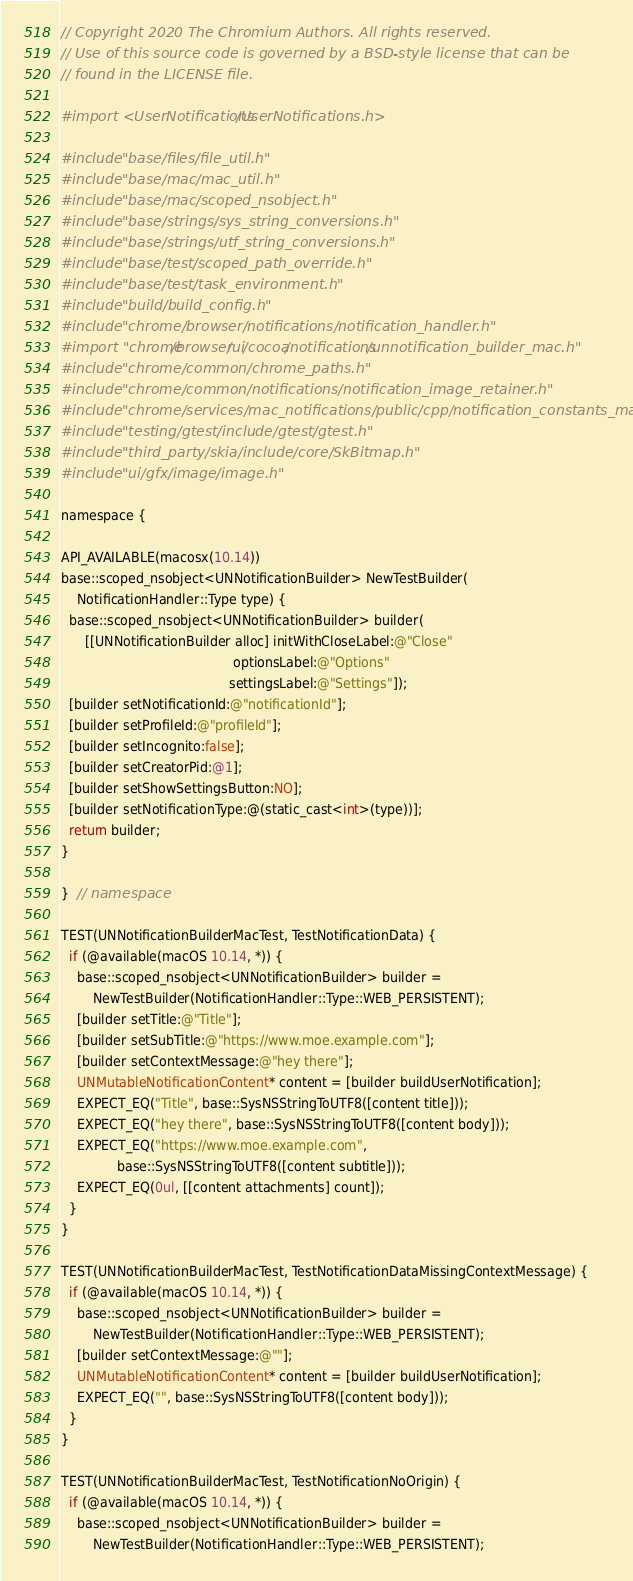Convert code to text. <code><loc_0><loc_0><loc_500><loc_500><_ObjectiveC_>// Copyright 2020 The Chromium Authors. All rights reserved.
// Use of this source code is governed by a BSD-style license that can be
// found in the LICENSE file.

#import <UserNotifications/UserNotifications.h>

#include "base/files/file_util.h"
#include "base/mac/mac_util.h"
#include "base/mac/scoped_nsobject.h"
#include "base/strings/sys_string_conversions.h"
#include "base/strings/utf_string_conversions.h"
#include "base/test/scoped_path_override.h"
#include "base/test/task_environment.h"
#include "build/build_config.h"
#include "chrome/browser/notifications/notification_handler.h"
#import "chrome/browser/ui/cocoa/notifications/unnotification_builder_mac.h"
#include "chrome/common/chrome_paths.h"
#include "chrome/common/notifications/notification_image_retainer.h"
#include "chrome/services/mac_notifications/public/cpp/notification_constants_mac.h"
#include "testing/gtest/include/gtest/gtest.h"
#include "third_party/skia/include/core/SkBitmap.h"
#include "ui/gfx/image/image.h"

namespace {

API_AVAILABLE(macosx(10.14))
base::scoped_nsobject<UNNotificationBuilder> NewTestBuilder(
    NotificationHandler::Type type) {
  base::scoped_nsobject<UNNotificationBuilder> builder(
      [[UNNotificationBuilder alloc] initWithCloseLabel:@"Close"
                                           optionsLabel:@"Options"
                                          settingsLabel:@"Settings"]);
  [builder setNotificationId:@"notificationId"];
  [builder setProfileId:@"profileId"];
  [builder setIncognito:false];
  [builder setCreatorPid:@1];
  [builder setShowSettingsButton:NO];
  [builder setNotificationType:@(static_cast<int>(type))];
  return builder;
}

}  // namespace

TEST(UNNotificationBuilderMacTest, TestNotificationData) {
  if (@available(macOS 10.14, *)) {
    base::scoped_nsobject<UNNotificationBuilder> builder =
        NewTestBuilder(NotificationHandler::Type::WEB_PERSISTENT);
    [builder setTitle:@"Title"];
    [builder setSubTitle:@"https://www.moe.example.com"];
    [builder setContextMessage:@"hey there"];
    UNMutableNotificationContent* content = [builder buildUserNotification];
    EXPECT_EQ("Title", base::SysNSStringToUTF8([content title]));
    EXPECT_EQ("hey there", base::SysNSStringToUTF8([content body]));
    EXPECT_EQ("https://www.moe.example.com",
              base::SysNSStringToUTF8([content subtitle]));
    EXPECT_EQ(0ul, [[content attachments] count]);
  }
}

TEST(UNNotificationBuilderMacTest, TestNotificationDataMissingContextMessage) {
  if (@available(macOS 10.14, *)) {
    base::scoped_nsobject<UNNotificationBuilder> builder =
        NewTestBuilder(NotificationHandler::Type::WEB_PERSISTENT);
    [builder setContextMessage:@""];
    UNMutableNotificationContent* content = [builder buildUserNotification];
    EXPECT_EQ("", base::SysNSStringToUTF8([content body]));
  }
}

TEST(UNNotificationBuilderMacTest, TestNotificationNoOrigin) {
  if (@available(macOS 10.14, *)) {
    base::scoped_nsobject<UNNotificationBuilder> builder =
        NewTestBuilder(NotificationHandler::Type::WEB_PERSISTENT);</code> 